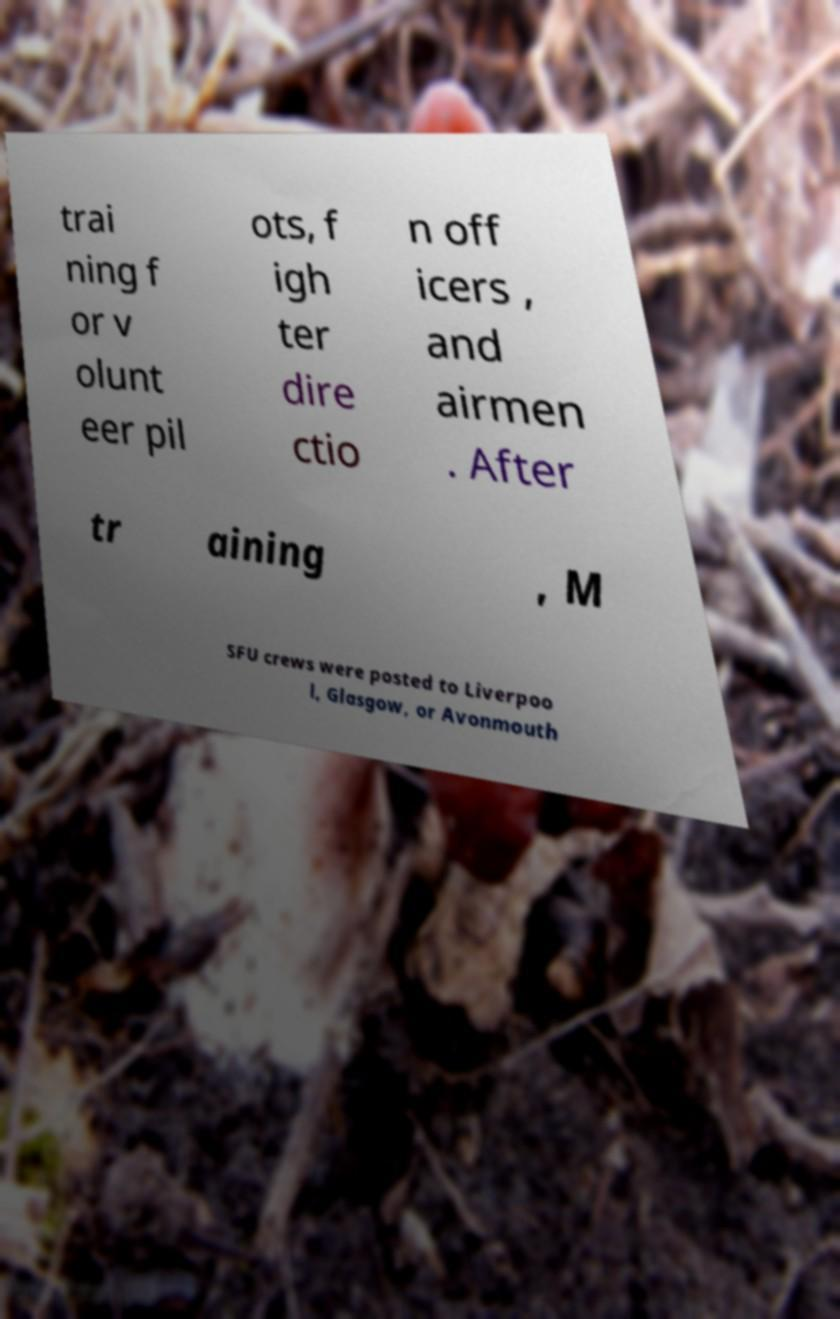Please identify and transcribe the text found in this image. trai ning f or v olunt eer pil ots, f igh ter dire ctio n off icers , and airmen . After tr aining , M SFU crews were posted to Liverpoo l, Glasgow, or Avonmouth 